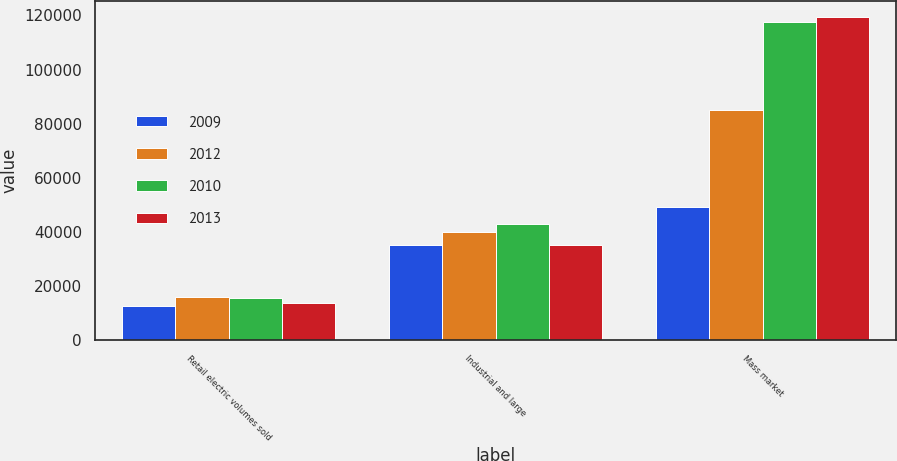<chart> <loc_0><loc_0><loc_500><loc_500><stacked_bar_chart><ecel><fcel>Retail electric volumes sold<fcel>Industrial and large<fcel>Mass market<nl><fcel>2009<fcel>12723<fcel>35056<fcel>49094<nl><fcel>2012<fcel>15993<fcel>40081<fcel>85191<nl><fcel>2010<fcel>15725<fcel>42983<fcel>117635<nl><fcel>2013<fcel>13840<fcel>35043<fcel>119276<nl></chart> 